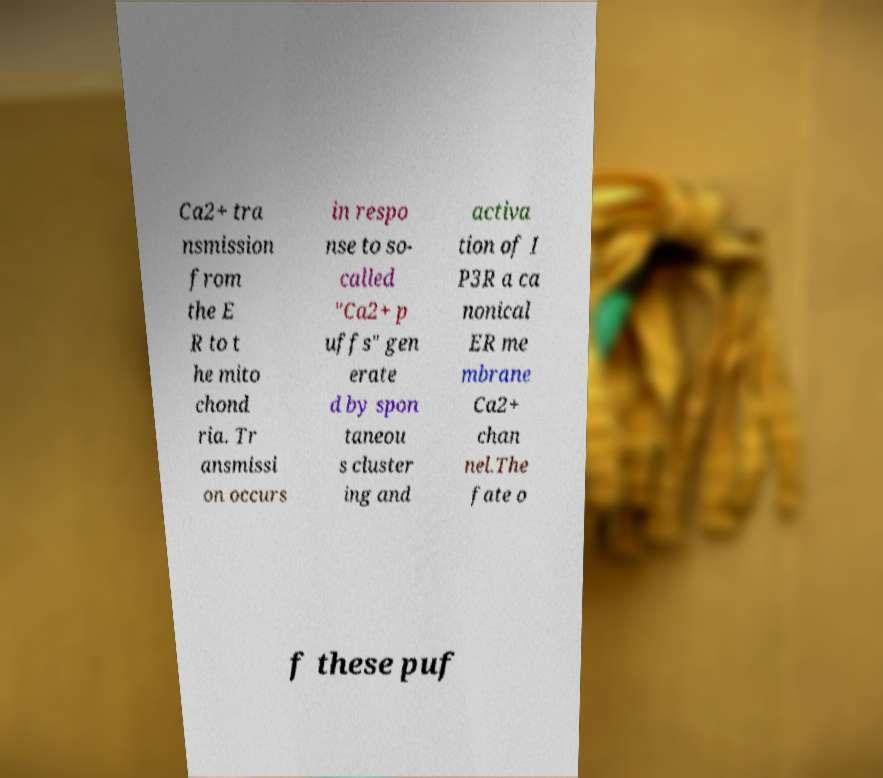I need the written content from this picture converted into text. Can you do that? Ca2+ tra nsmission from the E R to t he mito chond ria. Tr ansmissi on occurs in respo nse to so- called "Ca2+ p uffs" gen erate d by spon taneou s cluster ing and activa tion of I P3R a ca nonical ER me mbrane Ca2+ chan nel.The fate o f these puf 